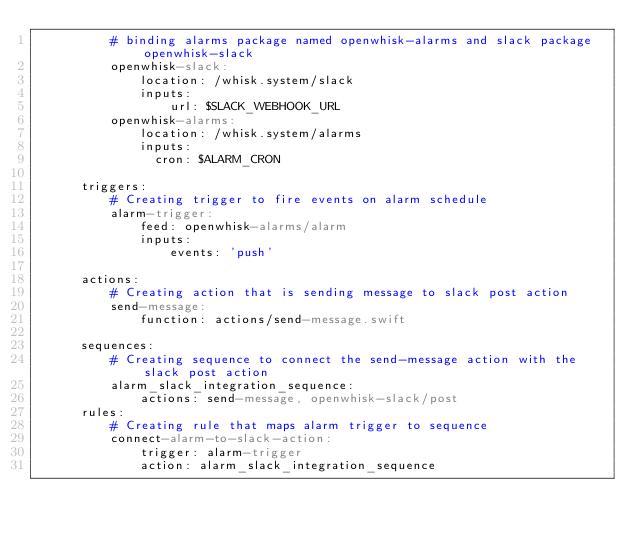Convert code to text. <code><loc_0><loc_0><loc_500><loc_500><_YAML_>          # binding alarms package named openwhisk-alarms and slack package openwhisk-slack
          openwhisk-slack:
              location: /whisk.system/slack
              inputs:
                  url: $SLACK_WEBHOOK_URL
          openwhisk-alarms:
              location: /whisk.system/alarms
              inputs:
                cron: $ALARM_CRON

      triggers:
          # Creating trigger to fire events on alarm schedule
          alarm-trigger:
              feed: openwhisk-alarms/alarm
              inputs:
                  events: 'push'

      actions:
          # Creating action that is sending message to slack post action
          send-message:
              function: actions/send-message.swift

      sequences:
          # Creating sequence to connect the send-message action with the slack post action
          alarm_slack_integration_sequence:
              actions: send-message, openwhisk-slack/post
      rules:
          # Creating rule that maps alarm trigger to sequence
          connect-alarm-to-slack-action:
              trigger: alarm-trigger
              action: alarm_slack_integration_sequence
</code> 